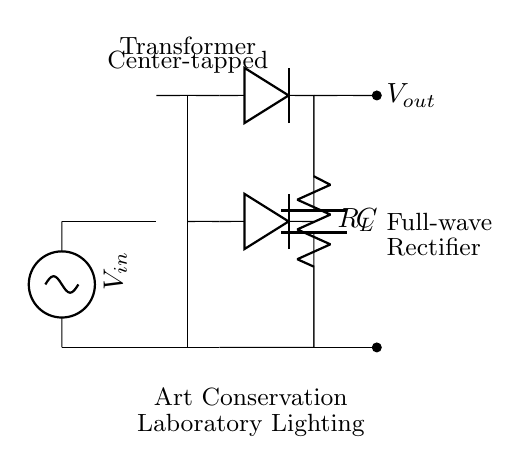What type of transformer is used in this circuit? The diagram shows a center-tapped transformer, which is indicated by the label near the transformer core. This type of transformer has a tap at the center of the winding, allowing for two equal voltage outputs from two halves of the winding.
Answer: center-tapped How many diodes are present in this circuit? The circuit diagram clearly shows two diodes connected to the outputs of the transformer. Each diode is responsible for rectifying one half of the AC input voltage.
Answer: two What is the role of the capacitor in this circuit? The capacitor is connected across the output terminals and is responsible for smoothing the rectified voltage. It stores energy and helps maintain a consistent output voltage by reducing ripples in the waveform.
Answer: smoothing What is the output voltage designation? The output is labeled as Vout in the circuit diagram, indicating the voltage available for the load connected across the output.
Answer: Vout Why is a full-wave rectifier used instead of a half-wave rectifier? A full-wave rectifier allows for the use of both halves of the AC waveform. This results in a higher average output voltage and more efficient power usage compared to a half-wave rectifier, which utilizes only one half of the input signal.
Answer: more efficient What kind of load is indicated in the circuit? The load is shown as R_L, which represents a resistive load. In this context, it signifies the load connected to the output, likely providing light in the art conservation laboratory.
Answer: resistive load 